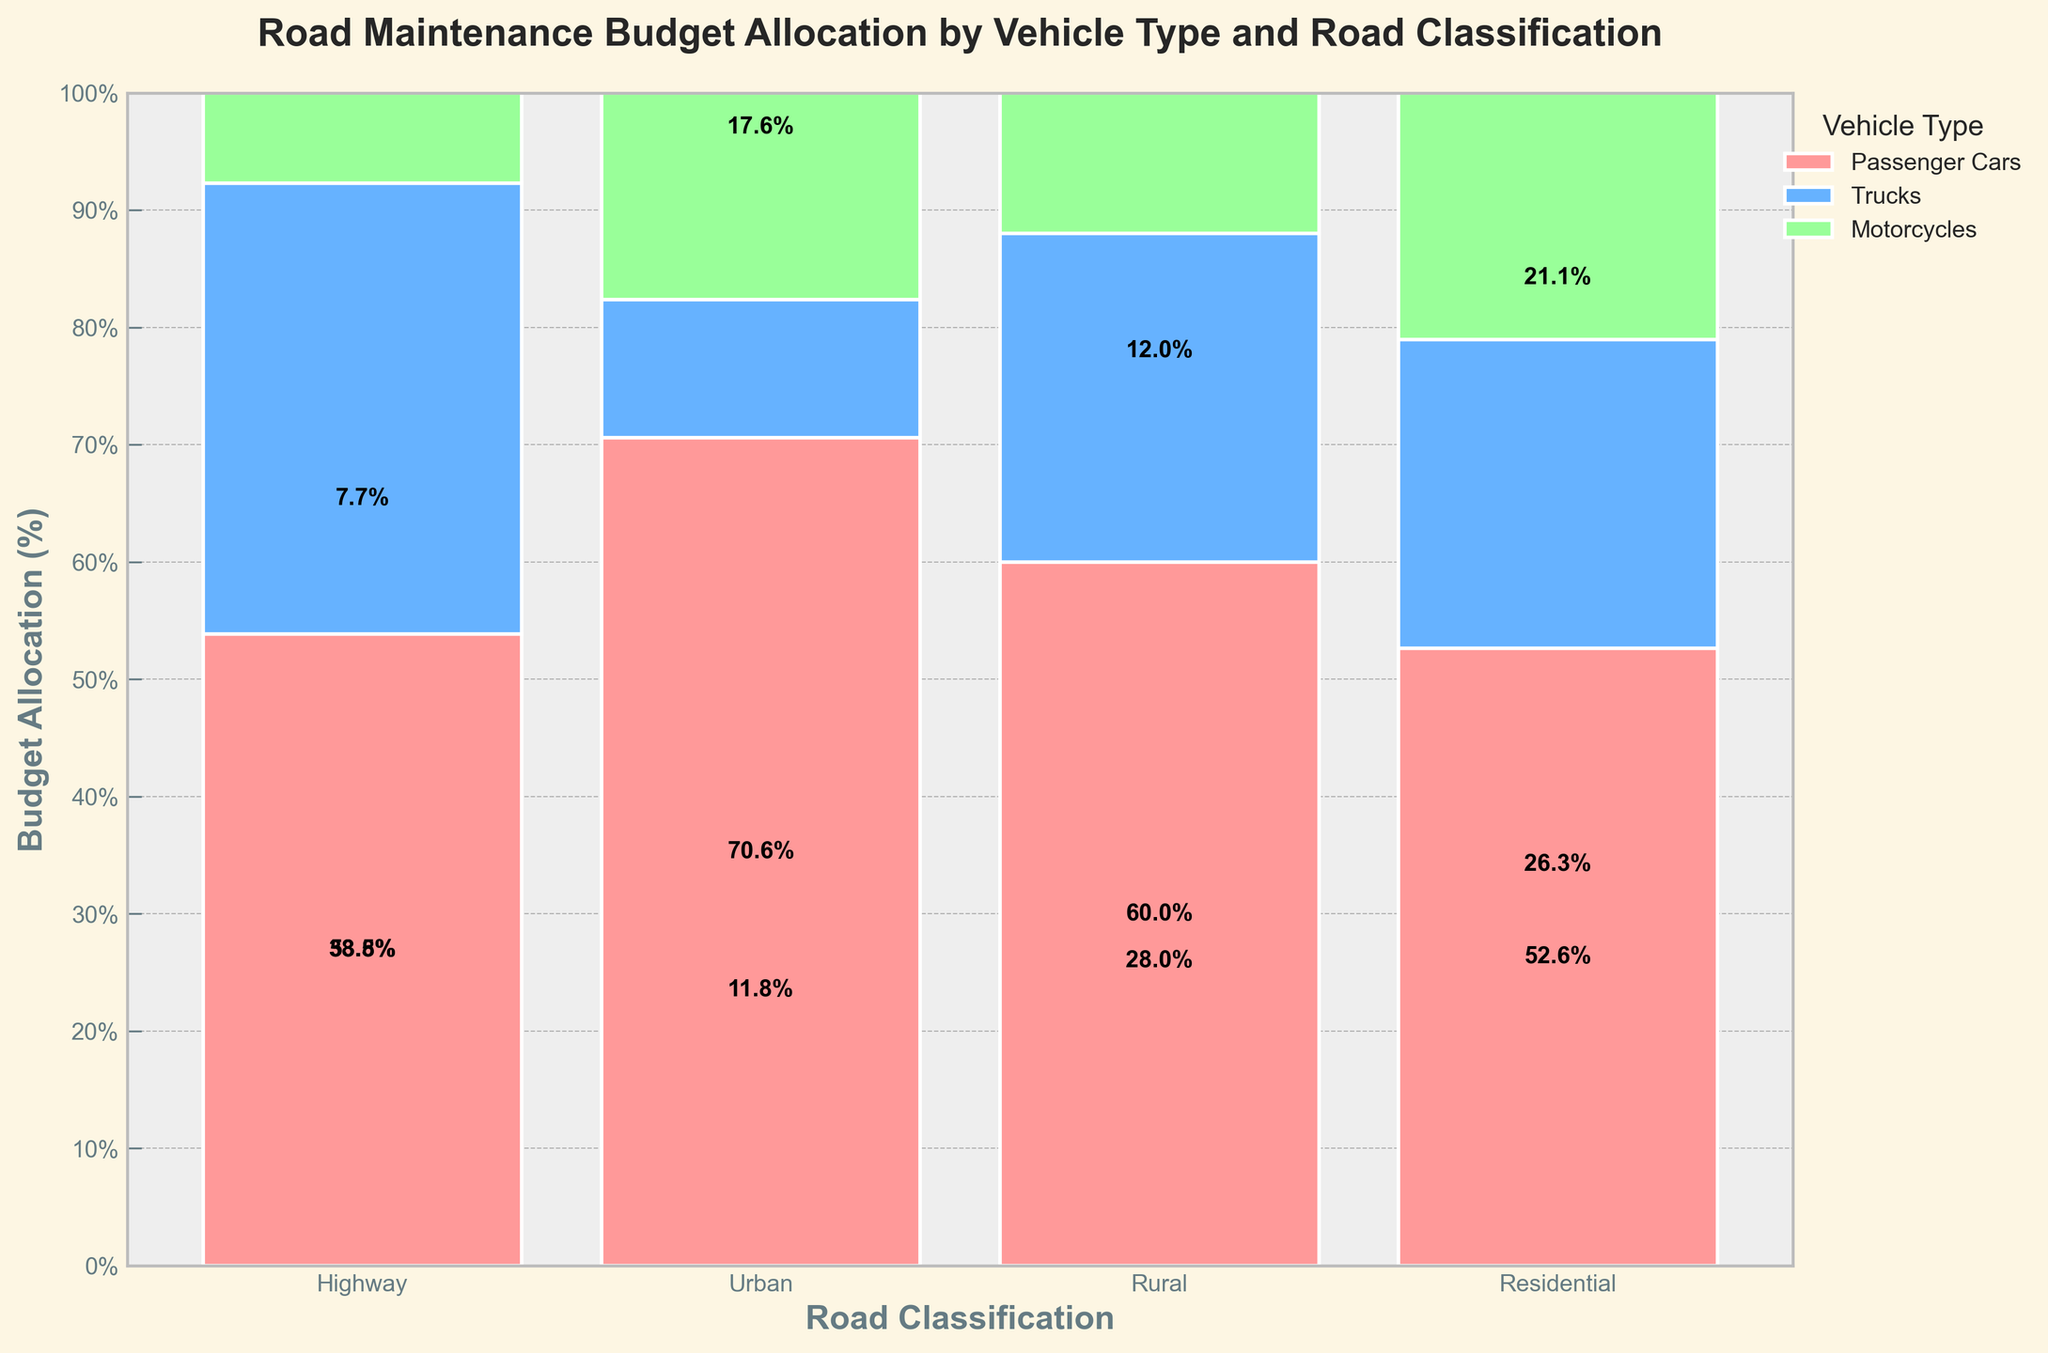What is the title of the figure? The title is usually placed at the top of the figure and provides an overview. Here, it is displayed prominently.
Answer: Road Maintenance Budget Allocation by Vehicle Type and Road Classification How much budget allocation is given to motorcycles on rural roads? Refer to the corresponding section for rural roads and look at the slice representing motorcycles. The plot will have percentage labels.
Answer: 6% Which road classification receives the highest budget allocation for passenger cars? Identify all the sections relating to passenger cars and compare their budget allocation percentages.
Answer: Highway What is the overall budget allocation percentage for trucks across all road classifications? Identify all the sections for trucks, sum their percentages, then reference the total. This requires calculating the weighted contribution by the total percentage shown in the legend.
Answer: 22% How are the budget allocations for urban roads distributed among different vehicle types? Analyze the slice for urban roads and compare the sizes of segments for each vehicle type.
Answer: Passenger Cars: 56%, Trucks: 28%, Motorcycles: 16% In which road classification do motorcycles receive the smallest budget allocation percentage? Analyze each section for motorcycles and identify the smallest percentage.
Answer: Rural Compare the budget allocation for trucks between highways and urban roads. Refer to the sections for trucks in both highways and urban roads and directly compare the percentages.
Answer: Highways: 41%, Urban: 16% What is the difference in budget allocation percentage between passenger cars on highways and those on rural roads? Extract the percentages for passenger cars on highways and rural roads and find the difference.
Answer: 28% How do budget allocations for passenger cars compare to trucks on residential roads? Review the sections for passenger cars and trucks on residential roads, then compare the sizes directly.
Answer: Passenger Cars: 67%, Trucks: 10% Which road classification gets the least overall budget allocation for road maintenance? Observe the overall height of each bar, representing the total budget.
Answer: Residential 